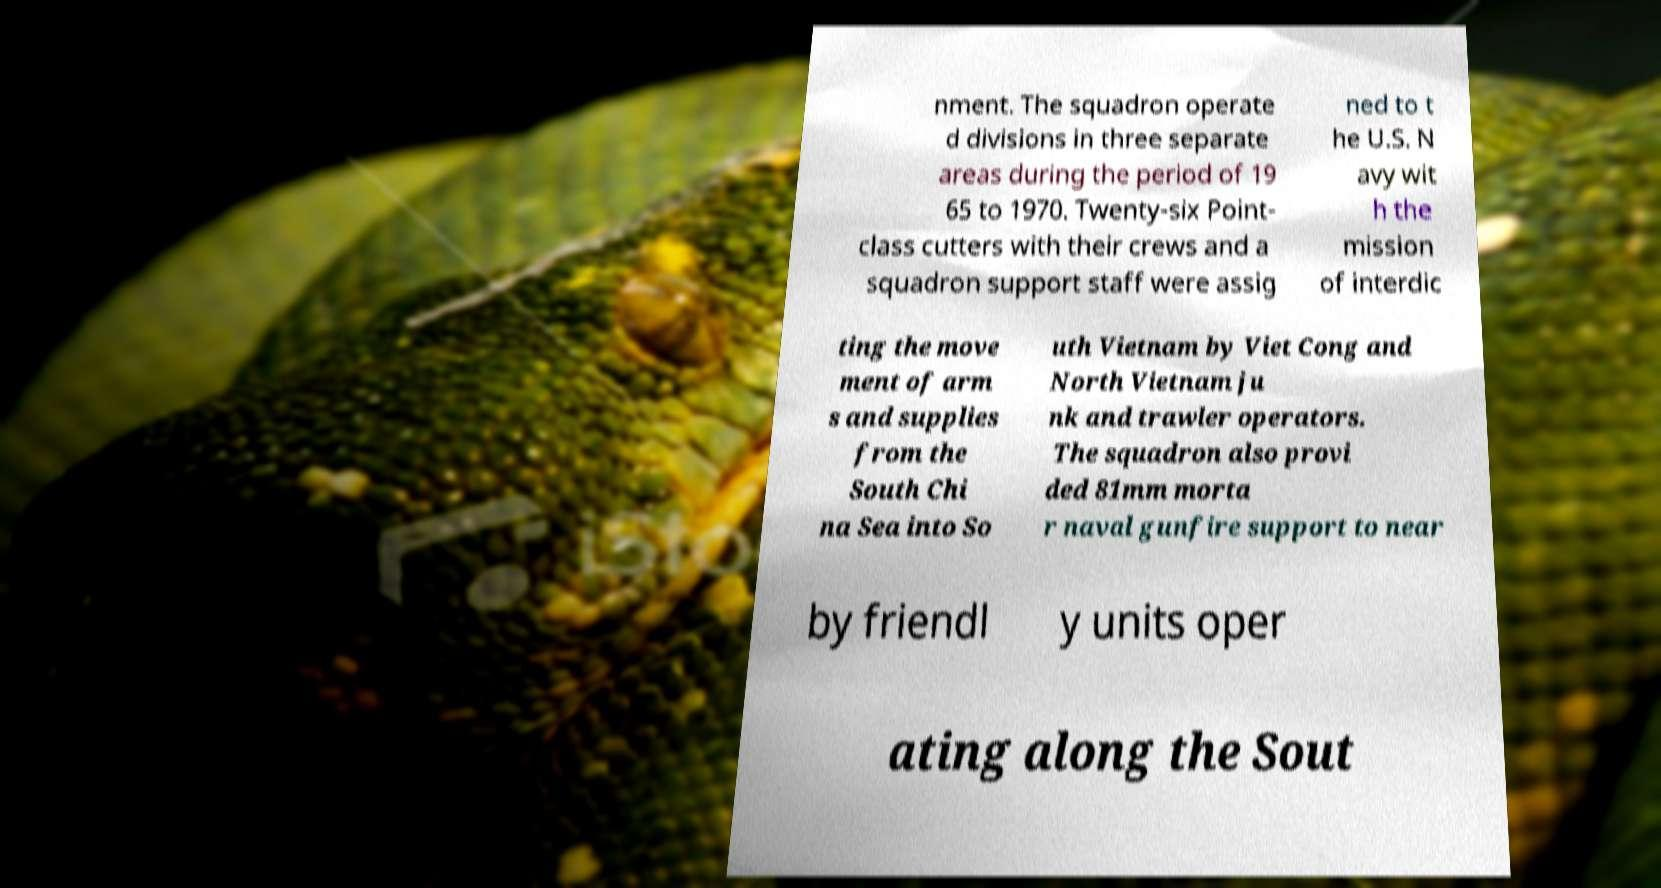Please identify and transcribe the text found in this image. nment. The squadron operate d divisions in three separate areas during the period of 19 65 to 1970. Twenty-six Point- class cutters with their crews and a squadron support staff were assig ned to t he U.S. N avy wit h the mission of interdic ting the move ment of arm s and supplies from the South Chi na Sea into So uth Vietnam by Viet Cong and North Vietnam ju nk and trawler operators. The squadron also provi ded 81mm morta r naval gunfire support to near by friendl y units oper ating along the Sout 